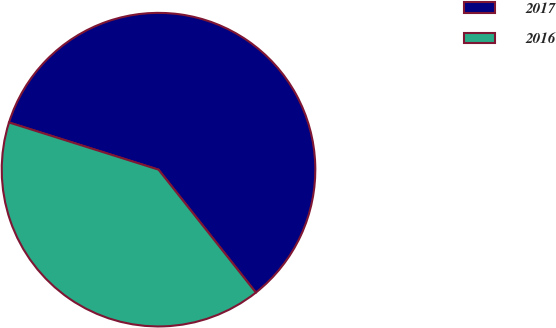Convert chart. <chart><loc_0><loc_0><loc_500><loc_500><pie_chart><fcel>2017<fcel>2016<nl><fcel>59.47%<fcel>40.53%<nl></chart> 